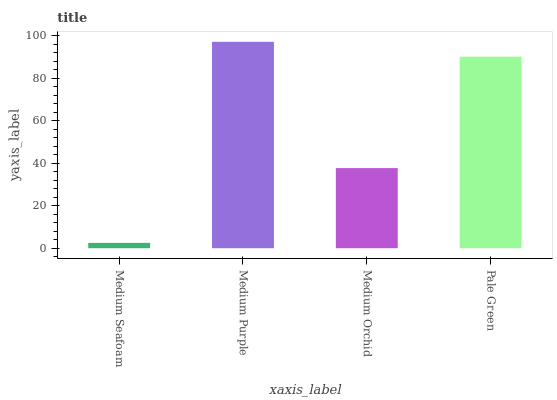Is Medium Seafoam the minimum?
Answer yes or no. Yes. Is Medium Purple the maximum?
Answer yes or no. Yes. Is Medium Orchid the minimum?
Answer yes or no. No. Is Medium Orchid the maximum?
Answer yes or no. No. Is Medium Purple greater than Medium Orchid?
Answer yes or no. Yes. Is Medium Orchid less than Medium Purple?
Answer yes or no. Yes. Is Medium Orchid greater than Medium Purple?
Answer yes or no. No. Is Medium Purple less than Medium Orchid?
Answer yes or no. No. Is Pale Green the high median?
Answer yes or no. Yes. Is Medium Orchid the low median?
Answer yes or no. Yes. Is Medium Orchid the high median?
Answer yes or no. No. Is Medium Seafoam the low median?
Answer yes or no. No. 